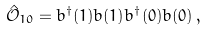<formula> <loc_0><loc_0><loc_500><loc_500>\hat { \mathcal { O } } _ { 1 0 } = b ^ { \dagger } ( 1 ) b ( 1 ) b ^ { \dagger } ( 0 ) b ( 0 ) \, ,</formula> 